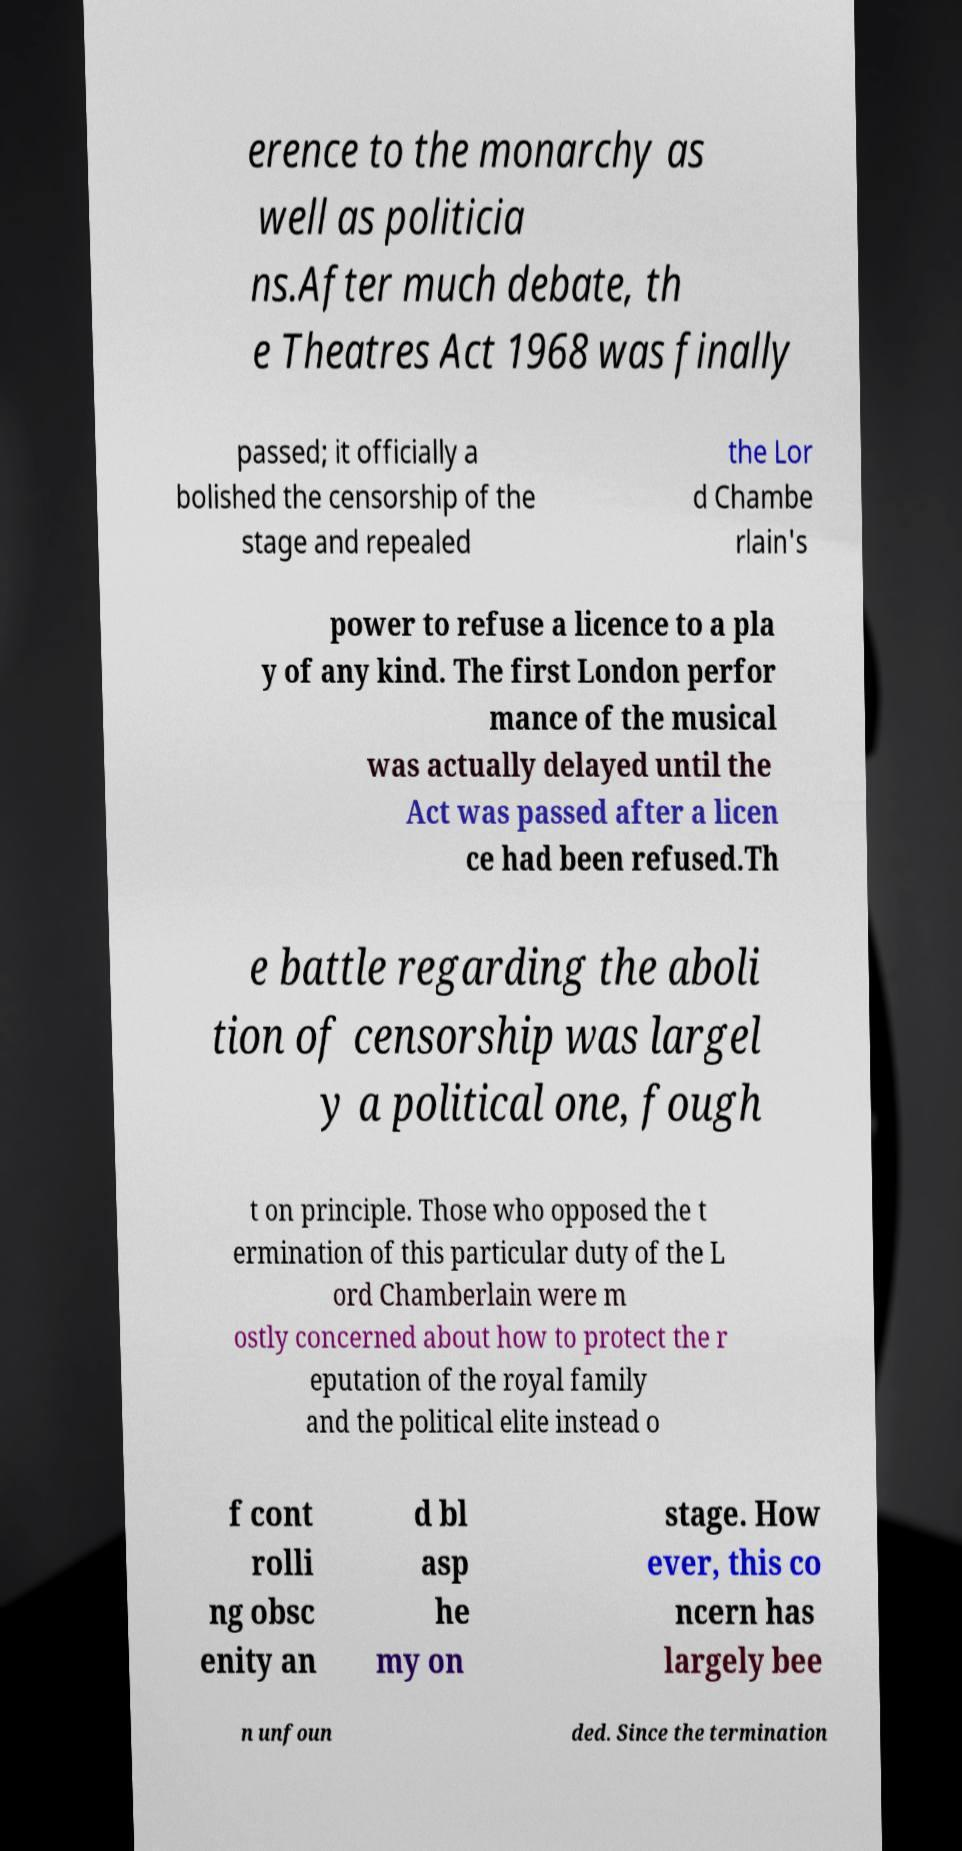Could you assist in decoding the text presented in this image and type it out clearly? erence to the monarchy as well as politicia ns.After much debate, th e Theatres Act 1968 was finally passed; it officially a bolished the censorship of the stage and repealed the Lor d Chambe rlain's power to refuse a licence to a pla y of any kind. The first London perfor mance of the musical was actually delayed until the Act was passed after a licen ce had been refused.Th e battle regarding the aboli tion of censorship was largel y a political one, fough t on principle. Those who opposed the t ermination of this particular duty of the L ord Chamberlain were m ostly concerned about how to protect the r eputation of the royal family and the political elite instead o f cont rolli ng obsc enity an d bl asp he my on stage. How ever, this co ncern has largely bee n unfoun ded. Since the termination 